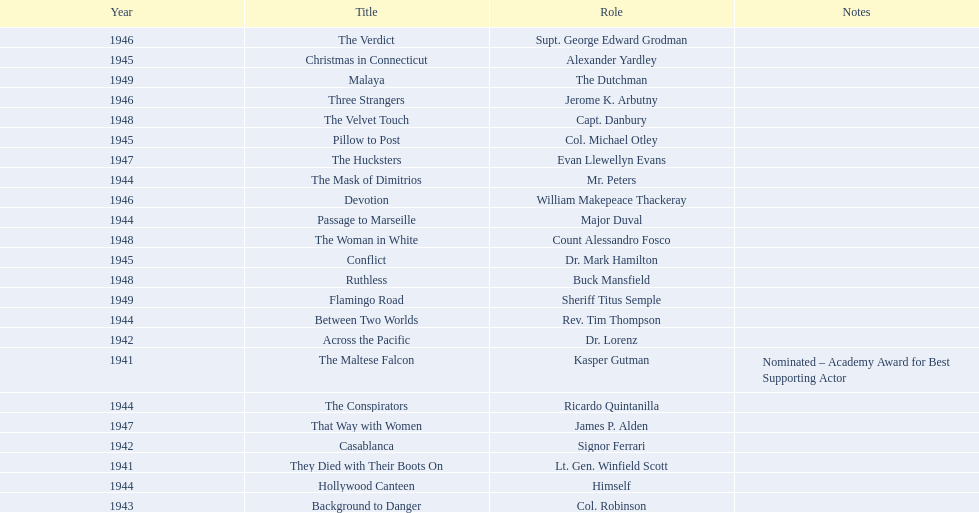What are the movies? The Maltese Falcon, They Died with Their Boots On, Across the Pacific, Casablanca, Background to Danger, Passage to Marseille, Between Two Worlds, The Mask of Dimitrios, The Conspirators, Hollywood Canteen, Pillow to Post, Conflict, Christmas in Connecticut, Three Strangers, Devotion, The Verdict, That Way with Women, The Hucksters, The Velvet Touch, Ruthless, The Woman in White, Flamingo Road, Malaya. Of these, for which did he get nominated for an oscar? The Maltese Falcon. 